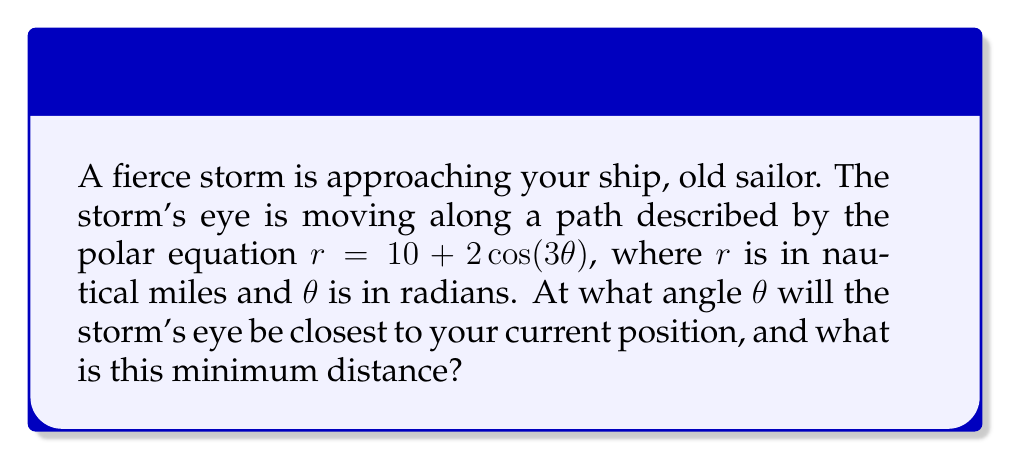Give your solution to this math problem. Let's approach this step-by-step:

1) To find the minimum distance, we need to find the minimum value of $r$ in the given equation:
   $r = 10 + 2\cos(3\theta)$

2) The minimum value of $r$ will occur when $\cos(3\theta)$ is at its minimum, which is -1.

3) $\cos(3\theta) = -1$ when $3\theta = \pi, 3\pi, 5\pi, ...$ or in general, $3\theta = (2n+1)\pi$ where $n$ is an integer.

4) Solving for $\theta$:
   $\theta = \frac{(2n+1)\pi}{3}$

5) The smallest positive value for $\theta$ occurs when $n = 0$:
   $\theta = \frac{\pi}{3}$ radians or 60°

6) To find the minimum distance, substitute this $\theta$ value back into the original equation:
   $r_{min} = 10 + 2\cos(3 \cdot \frac{\pi}{3})$
   $r_{min} = 10 + 2\cos(\pi)$
   $r_{min} = 10 + 2(-1)$
   $r_{min} = 10 - 2 = 8$ nautical miles

Therefore, the storm's eye will be closest to your position when $\theta = \frac{\pi}{3}$ radians or 60°, and the minimum distance will be 8 nautical miles.
Answer: $\theta = \frac{\pi}{3}$, $r_{min} = 8$ nautical miles 